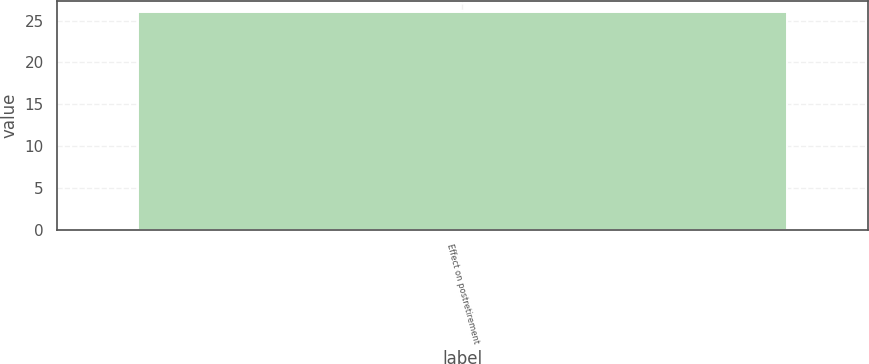<chart> <loc_0><loc_0><loc_500><loc_500><bar_chart><fcel>Effect on postretirement<nl><fcel>26<nl></chart> 